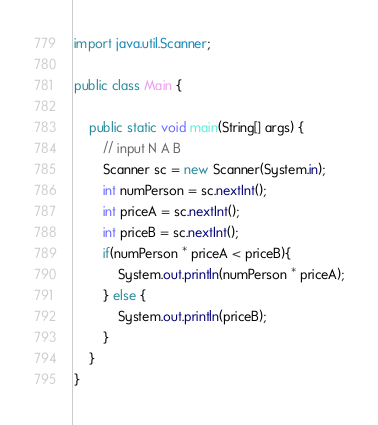<code> <loc_0><loc_0><loc_500><loc_500><_Java_>import java.util.Scanner;

public class Main {

    public static void main(String[] args) {
	    // input N A B
        Scanner sc = new Scanner(System.in);
        int numPerson = sc.nextInt();
        int priceA = sc.nextInt();
        int priceB = sc.nextInt();
        if(numPerson * priceA < priceB){
            System.out.println(numPerson * priceA);
        } else {
            System.out.println(priceB);
        }
    }
}</code> 